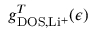<formula> <loc_0><loc_0><loc_500><loc_500>g _ { D O S , L i ^ { + } } ^ { T } ( \epsilon )</formula> 